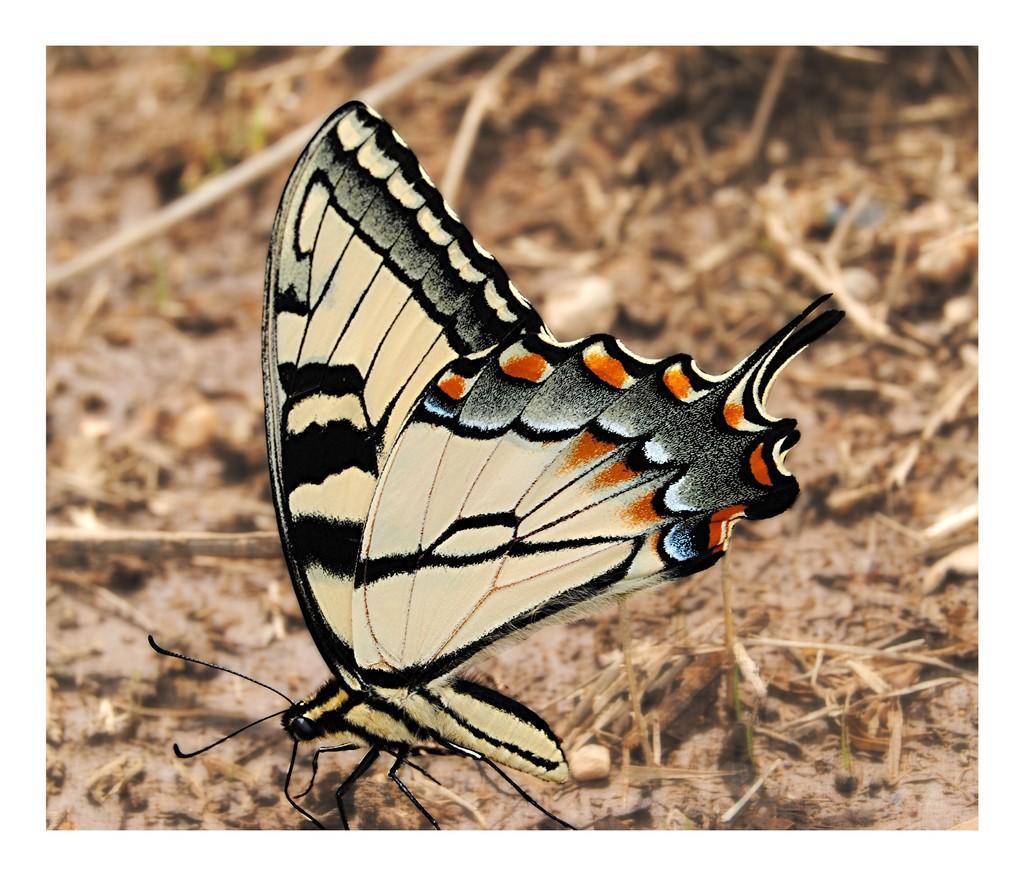In one or two sentences, can you explain what this image depicts? In this picture we can observe a butterfly which is in black, cream and orange colors. This butterfly is on the land. We can observe some sticks in the background. 